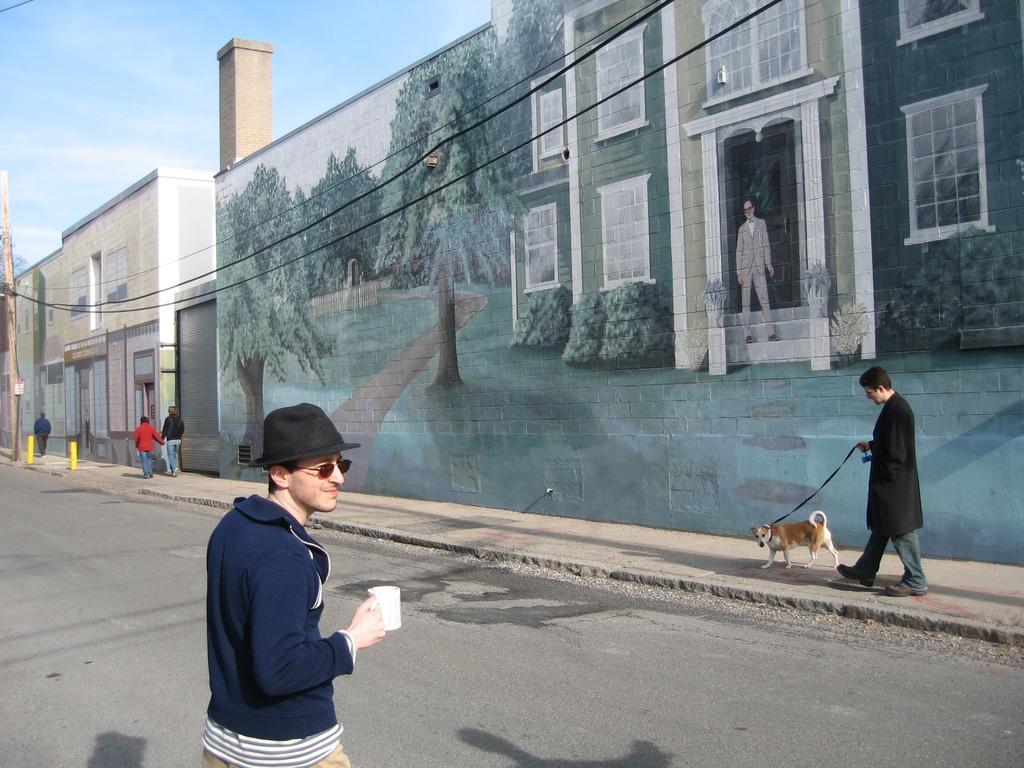How would you summarize this image in a sentence or two? In this picture we can see man holding cup in his hand and standing on road and aside to this road we have some persons walking on foot path along with the dog and in the background we can see wall with paintings, wires, sky with clouds, pole. 